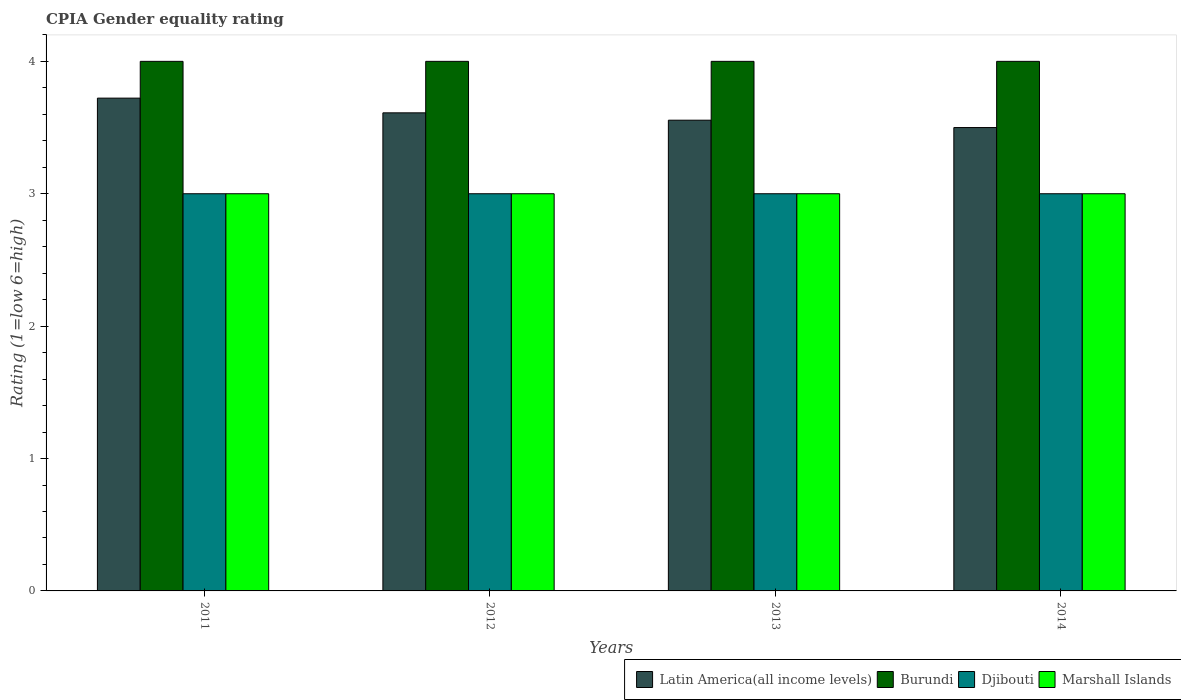How many different coloured bars are there?
Make the answer very short. 4. Are the number of bars per tick equal to the number of legend labels?
Offer a terse response. Yes. Are the number of bars on each tick of the X-axis equal?
Provide a short and direct response. Yes. How many bars are there on the 4th tick from the left?
Your answer should be very brief. 4. How many bars are there on the 4th tick from the right?
Give a very brief answer. 4. What is the CPIA rating in Latin America(all income levels) in 2011?
Provide a succinct answer. 3.72. In which year was the CPIA rating in Burundi maximum?
Your answer should be very brief. 2011. In which year was the CPIA rating in Latin America(all income levels) minimum?
Your answer should be very brief. 2014. What is the difference between the CPIA rating in Burundi in 2011 and that in 2014?
Provide a short and direct response. 0. What is the difference between the CPIA rating in Djibouti in 2012 and the CPIA rating in Marshall Islands in 2013?
Your answer should be compact. 0. What is the average CPIA rating in Djibouti per year?
Offer a very short reply. 3. In how many years, is the CPIA rating in Burundi greater than 3.2?
Ensure brevity in your answer.  4. What is the ratio of the CPIA rating in Latin America(all income levels) in 2012 to that in 2014?
Your response must be concise. 1.03. What is the difference between the highest and the lowest CPIA rating in Djibouti?
Ensure brevity in your answer.  0. Is the sum of the CPIA rating in Latin America(all income levels) in 2011 and 2012 greater than the maximum CPIA rating in Burundi across all years?
Make the answer very short. Yes. Is it the case that in every year, the sum of the CPIA rating in Djibouti and CPIA rating in Burundi is greater than the sum of CPIA rating in Marshall Islands and CPIA rating in Latin America(all income levels)?
Provide a succinct answer. No. What does the 4th bar from the left in 2013 represents?
Give a very brief answer. Marshall Islands. What does the 4th bar from the right in 2013 represents?
Your response must be concise. Latin America(all income levels). Is it the case that in every year, the sum of the CPIA rating in Djibouti and CPIA rating in Marshall Islands is greater than the CPIA rating in Burundi?
Your answer should be compact. Yes. How many bars are there?
Ensure brevity in your answer.  16. Are all the bars in the graph horizontal?
Make the answer very short. No. What is the difference between two consecutive major ticks on the Y-axis?
Your answer should be compact. 1. Does the graph contain any zero values?
Your answer should be compact. No. Where does the legend appear in the graph?
Your answer should be compact. Bottom right. How many legend labels are there?
Provide a succinct answer. 4. What is the title of the graph?
Offer a terse response. CPIA Gender equality rating. What is the Rating (1=low 6=high) of Latin America(all income levels) in 2011?
Give a very brief answer. 3.72. What is the Rating (1=low 6=high) of Djibouti in 2011?
Your response must be concise. 3. What is the Rating (1=low 6=high) of Marshall Islands in 2011?
Ensure brevity in your answer.  3. What is the Rating (1=low 6=high) of Latin America(all income levels) in 2012?
Offer a very short reply. 3.61. What is the Rating (1=low 6=high) of Burundi in 2012?
Give a very brief answer. 4. What is the Rating (1=low 6=high) in Latin America(all income levels) in 2013?
Your answer should be compact. 3.56. What is the Rating (1=low 6=high) of Burundi in 2013?
Provide a succinct answer. 4. What is the Rating (1=low 6=high) of Djibouti in 2013?
Offer a terse response. 3. What is the Rating (1=low 6=high) in Latin America(all income levels) in 2014?
Keep it short and to the point. 3.5. Across all years, what is the maximum Rating (1=low 6=high) in Latin America(all income levels)?
Give a very brief answer. 3.72. Across all years, what is the minimum Rating (1=low 6=high) in Burundi?
Make the answer very short. 4. Across all years, what is the minimum Rating (1=low 6=high) in Djibouti?
Provide a short and direct response. 3. Across all years, what is the minimum Rating (1=low 6=high) of Marshall Islands?
Your answer should be compact. 3. What is the total Rating (1=low 6=high) of Latin America(all income levels) in the graph?
Offer a terse response. 14.39. What is the total Rating (1=low 6=high) of Marshall Islands in the graph?
Offer a very short reply. 12. What is the difference between the Rating (1=low 6=high) of Latin America(all income levels) in 2011 and that in 2012?
Offer a terse response. 0.11. What is the difference between the Rating (1=low 6=high) of Latin America(all income levels) in 2011 and that in 2013?
Give a very brief answer. 0.17. What is the difference between the Rating (1=low 6=high) of Marshall Islands in 2011 and that in 2013?
Provide a succinct answer. 0. What is the difference between the Rating (1=low 6=high) of Latin America(all income levels) in 2011 and that in 2014?
Your response must be concise. 0.22. What is the difference between the Rating (1=low 6=high) in Djibouti in 2011 and that in 2014?
Your response must be concise. 0. What is the difference between the Rating (1=low 6=high) in Marshall Islands in 2011 and that in 2014?
Provide a succinct answer. 0. What is the difference between the Rating (1=low 6=high) in Latin America(all income levels) in 2012 and that in 2013?
Your answer should be compact. 0.06. What is the difference between the Rating (1=low 6=high) in Marshall Islands in 2012 and that in 2013?
Make the answer very short. 0. What is the difference between the Rating (1=low 6=high) in Djibouti in 2012 and that in 2014?
Offer a terse response. 0. What is the difference between the Rating (1=low 6=high) of Latin America(all income levels) in 2013 and that in 2014?
Give a very brief answer. 0.06. What is the difference between the Rating (1=low 6=high) of Burundi in 2013 and that in 2014?
Your answer should be compact. 0. What is the difference between the Rating (1=low 6=high) in Latin America(all income levels) in 2011 and the Rating (1=low 6=high) in Burundi in 2012?
Provide a short and direct response. -0.28. What is the difference between the Rating (1=low 6=high) of Latin America(all income levels) in 2011 and the Rating (1=low 6=high) of Djibouti in 2012?
Provide a succinct answer. 0.72. What is the difference between the Rating (1=low 6=high) of Latin America(all income levels) in 2011 and the Rating (1=low 6=high) of Marshall Islands in 2012?
Provide a short and direct response. 0.72. What is the difference between the Rating (1=low 6=high) of Burundi in 2011 and the Rating (1=low 6=high) of Djibouti in 2012?
Make the answer very short. 1. What is the difference between the Rating (1=low 6=high) of Burundi in 2011 and the Rating (1=low 6=high) of Marshall Islands in 2012?
Offer a very short reply. 1. What is the difference between the Rating (1=low 6=high) of Djibouti in 2011 and the Rating (1=low 6=high) of Marshall Islands in 2012?
Offer a very short reply. 0. What is the difference between the Rating (1=low 6=high) of Latin America(all income levels) in 2011 and the Rating (1=low 6=high) of Burundi in 2013?
Ensure brevity in your answer.  -0.28. What is the difference between the Rating (1=low 6=high) of Latin America(all income levels) in 2011 and the Rating (1=low 6=high) of Djibouti in 2013?
Keep it short and to the point. 0.72. What is the difference between the Rating (1=low 6=high) in Latin America(all income levels) in 2011 and the Rating (1=low 6=high) in Marshall Islands in 2013?
Offer a terse response. 0.72. What is the difference between the Rating (1=low 6=high) of Burundi in 2011 and the Rating (1=low 6=high) of Djibouti in 2013?
Ensure brevity in your answer.  1. What is the difference between the Rating (1=low 6=high) of Latin America(all income levels) in 2011 and the Rating (1=low 6=high) of Burundi in 2014?
Ensure brevity in your answer.  -0.28. What is the difference between the Rating (1=low 6=high) of Latin America(all income levels) in 2011 and the Rating (1=low 6=high) of Djibouti in 2014?
Make the answer very short. 0.72. What is the difference between the Rating (1=low 6=high) of Latin America(all income levels) in 2011 and the Rating (1=low 6=high) of Marshall Islands in 2014?
Offer a very short reply. 0.72. What is the difference between the Rating (1=low 6=high) of Burundi in 2011 and the Rating (1=low 6=high) of Djibouti in 2014?
Offer a very short reply. 1. What is the difference between the Rating (1=low 6=high) of Burundi in 2011 and the Rating (1=low 6=high) of Marshall Islands in 2014?
Provide a succinct answer. 1. What is the difference between the Rating (1=low 6=high) in Latin America(all income levels) in 2012 and the Rating (1=low 6=high) in Burundi in 2013?
Your response must be concise. -0.39. What is the difference between the Rating (1=low 6=high) of Latin America(all income levels) in 2012 and the Rating (1=low 6=high) of Djibouti in 2013?
Provide a succinct answer. 0.61. What is the difference between the Rating (1=low 6=high) of Latin America(all income levels) in 2012 and the Rating (1=low 6=high) of Marshall Islands in 2013?
Offer a very short reply. 0.61. What is the difference between the Rating (1=low 6=high) of Burundi in 2012 and the Rating (1=low 6=high) of Djibouti in 2013?
Offer a terse response. 1. What is the difference between the Rating (1=low 6=high) in Burundi in 2012 and the Rating (1=low 6=high) in Marshall Islands in 2013?
Provide a short and direct response. 1. What is the difference between the Rating (1=low 6=high) in Djibouti in 2012 and the Rating (1=low 6=high) in Marshall Islands in 2013?
Ensure brevity in your answer.  0. What is the difference between the Rating (1=low 6=high) of Latin America(all income levels) in 2012 and the Rating (1=low 6=high) of Burundi in 2014?
Make the answer very short. -0.39. What is the difference between the Rating (1=low 6=high) of Latin America(all income levels) in 2012 and the Rating (1=low 6=high) of Djibouti in 2014?
Offer a very short reply. 0.61. What is the difference between the Rating (1=low 6=high) of Latin America(all income levels) in 2012 and the Rating (1=low 6=high) of Marshall Islands in 2014?
Your answer should be very brief. 0.61. What is the difference between the Rating (1=low 6=high) in Burundi in 2012 and the Rating (1=low 6=high) in Djibouti in 2014?
Your response must be concise. 1. What is the difference between the Rating (1=low 6=high) of Burundi in 2012 and the Rating (1=low 6=high) of Marshall Islands in 2014?
Your answer should be compact. 1. What is the difference between the Rating (1=low 6=high) in Latin America(all income levels) in 2013 and the Rating (1=low 6=high) in Burundi in 2014?
Offer a very short reply. -0.44. What is the difference between the Rating (1=low 6=high) in Latin America(all income levels) in 2013 and the Rating (1=low 6=high) in Djibouti in 2014?
Offer a terse response. 0.56. What is the difference between the Rating (1=low 6=high) of Latin America(all income levels) in 2013 and the Rating (1=low 6=high) of Marshall Islands in 2014?
Give a very brief answer. 0.56. What is the difference between the Rating (1=low 6=high) in Burundi in 2013 and the Rating (1=low 6=high) in Djibouti in 2014?
Provide a short and direct response. 1. What is the difference between the Rating (1=low 6=high) of Djibouti in 2013 and the Rating (1=low 6=high) of Marshall Islands in 2014?
Your response must be concise. 0. What is the average Rating (1=low 6=high) of Latin America(all income levels) per year?
Your response must be concise. 3.6. What is the average Rating (1=low 6=high) of Burundi per year?
Provide a short and direct response. 4. What is the average Rating (1=low 6=high) of Djibouti per year?
Offer a terse response. 3. What is the average Rating (1=low 6=high) in Marshall Islands per year?
Provide a short and direct response. 3. In the year 2011, what is the difference between the Rating (1=low 6=high) in Latin America(all income levels) and Rating (1=low 6=high) in Burundi?
Offer a very short reply. -0.28. In the year 2011, what is the difference between the Rating (1=low 6=high) of Latin America(all income levels) and Rating (1=low 6=high) of Djibouti?
Ensure brevity in your answer.  0.72. In the year 2011, what is the difference between the Rating (1=low 6=high) in Latin America(all income levels) and Rating (1=low 6=high) in Marshall Islands?
Ensure brevity in your answer.  0.72. In the year 2011, what is the difference between the Rating (1=low 6=high) of Burundi and Rating (1=low 6=high) of Djibouti?
Keep it short and to the point. 1. In the year 2011, what is the difference between the Rating (1=low 6=high) of Burundi and Rating (1=low 6=high) of Marshall Islands?
Keep it short and to the point. 1. In the year 2012, what is the difference between the Rating (1=low 6=high) of Latin America(all income levels) and Rating (1=low 6=high) of Burundi?
Provide a succinct answer. -0.39. In the year 2012, what is the difference between the Rating (1=low 6=high) in Latin America(all income levels) and Rating (1=low 6=high) in Djibouti?
Your answer should be compact. 0.61. In the year 2012, what is the difference between the Rating (1=low 6=high) of Latin America(all income levels) and Rating (1=low 6=high) of Marshall Islands?
Your response must be concise. 0.61. In the year 2012, what is the difference between the Rating (1=low 6=high) of Burundi and Rating (1=low 6=high) of Djibouti?
Offer a terse response. 1. In the year 2012, what is the difference between the Rating (1=low 6=high) of Burundi and Rating (1=low 6=high) of Marshall Islands?
Offer a terse response. 1. In the year 2013, what is the difference between the Rating (1=low 6=high) in Latin America(all income levels) and Rating (1=low 6=high) in Burundi?
Your answer should be very brief. -0.44. In the year 2013, what is the difference between the Rating (1=low 6=high) in Latin America(all income levels) and Rating (1=low 6=high) in Djibouti?
Your answer should be very brief. 0.56. In the year 2013, what is the difference between the Rating (1=low 6=high) in Latin America(all income levels) and Rating (1=low 6=high) in Marshall Islands?
Provide a succinct answer. 0.56. In the year 2013, what is the difference between the Rating (1=low 6=high) in Burundi and Rating (1=low 6=high) in Marshall Islands?
Give a very brief answer. 1. In the year 2014, what is the difference between the Rating (1=low 6=high) of Latin America(all income levels) and Rating (1=low 6=high) of Djibouti?
Your answer should be compact. 0.5. In the year 2014, what is the difference between the Rating (1=low 6=high) in Latin America(all income levels) and Rating (1=low 6=high) in Marshall Islands?
Your response must be concise. 0.5. In the year 2014, what is the difference between the Rating (1=low 6=high) in Burundi and Rating (1=low 6=high) in Djibouti?
Your answer should be very brief. 1. What is the ratio of the Rating (1=low 6=high) in Latin America(all income levels) in 2011 to that in 2012?
Offer a very short reply. 1.03. What is the ratio of the Rating (1=low 6=high) of Burundi in 2011 to that in 2012?
Give a very brief answer. 1. What is the ratio of the Rating (1=low 6=high) of Djibouti in 2011 to that in 2012?
Keep it short and to the point. 1. What is the ratio of the Rating (1=low 6=high) in Marshall Islands in 2011 to that in 2012?
Keep it short and to the point. 1. What is the ratio of the Rating (1=low 6=high) of Latin America(all income levels) in 2011 to that in 2013?
Your answer should be very brief. 1.05. What is the ratio of the Rating (1=low 6=high) of Latin America(all income levels) in 2011 to that in 2014?
Provide a succinct answer. 1.06. What is the ratio of the Rating (1=low 6=high) in Latin America(all income levels) in 2012 to that in 2013?
Make the answer very short. 1.02. What is the ratio of the Rating (1=low 6=high) in Burundi in 2012 to that in 2013?
Your answer should be very brief. 1. What is the ratio of the Rating (1=low 6=high) in Marshall Islands in 2012 to that in 2013?
Your answer should be compact. 1. What is the ratio of the Rating (1=low 6=high) in Latin America(all income levels) in 2012 to that in 2014?
Provide a short and direct response. 1.03. What is the ratio of the Rating (1=low 6=high) in Djibouti in 2012 to that in 2014?
Give a very brief answer. 1. What is the ratio of the Rating (1=low 6=high) in Marshall Islands in 2012 to that in 2014?
Your answer should be compact. 1. What is the ratio of the Rating (1=low 6=high) in Latin America(all income levels) in 2013 to that in 2014?
Offer a terse response. 1.02. What is the ratio of the Rating (1=low 6=high) of Burundi in 2013 to that in 2014?
Keep it short and to the point. 1. What is the ratio of the Rating (1=low 6=high) in Djibouti in 2013 to that in 2014?
Your answer should be compact. 1. What is the ratio of the Rating (1=low 6=high) of Marshall Islands in 2013 to that in 2014?
Provide a short and direct response. 1. What is the difference between the highest and the second highest Rating (1=low 6=high) in Burundi?
Make the answer very short. 0. What is the difference between the highest and the second highest Rating (1=low 6=high) of Djibouti?
Ensure brevity in your answer.  0. What is the difference between the highest and the lowest Rating (1=low 6=high) of Latin America(all income levels)?
Make the answer very short. 0.22. 